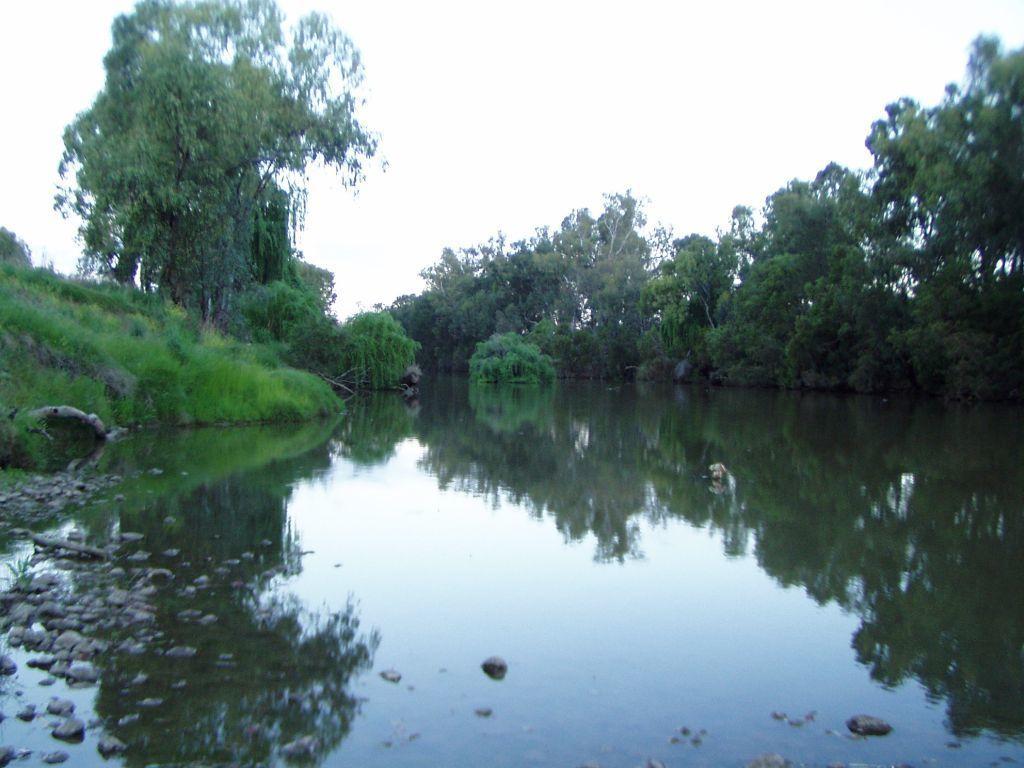Could you give a brief overview of what you see in this image? This picture might be taken from outside of the city. In this image, on the right side, we can see some trees and plants. On the left side, we can also see some trees, plants and stones. On the top, we can see a sky, at the bottom there is a water in a lake with some stones. 